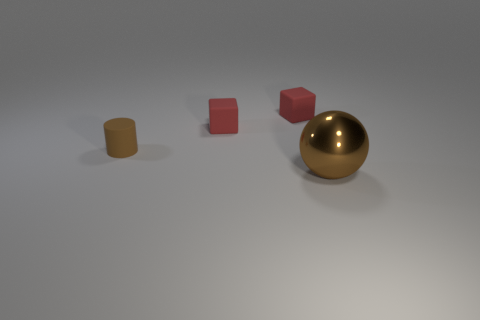What is the brown object in front of the brown thing to the left of the brown sphere made of?
Your response must be concise. Metal. What number of other objects are there of the same shape as the tiny brown matte thing?
Ensure brevity in your answer.  0. Are there any other things that are the same material as the big brown thing?
Ensure brevity in your answer.  No. What is the brown cylinder made of?
Ensure brevity in your answer.  Rubber. What material is the brown object left of the large metal sphere?
Give a very brief answer. Rubber. Is there any other thing that has the same color as the big thing?
Your answer should be very brief. Yes. What number of small objects are either brown things or red matte cubes?
Provide a succinct answer. 3. What size is the brown object that is behind the object in front of the brown object behind the big object?
Your answer should be compact. Small. How many brown things have the same size as the brown sphere?
Keep it short and to the point. 0. How many things are either yellow metal balls or small matte objects that are behind the small brown matte cylinder?
Make the answer very short. 2. 